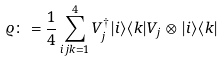<formula> <loc_0><loc_0><loc_500><loc_500>\varrho \colon = \frac { 1 } { 4 } \sum _ { i j k = 1 } ^ { 4 } V _ { j } ^ { \dagger } | i \rangle \langle k | V _ { j } \otimes | i \rangle \langle k |</formula> 